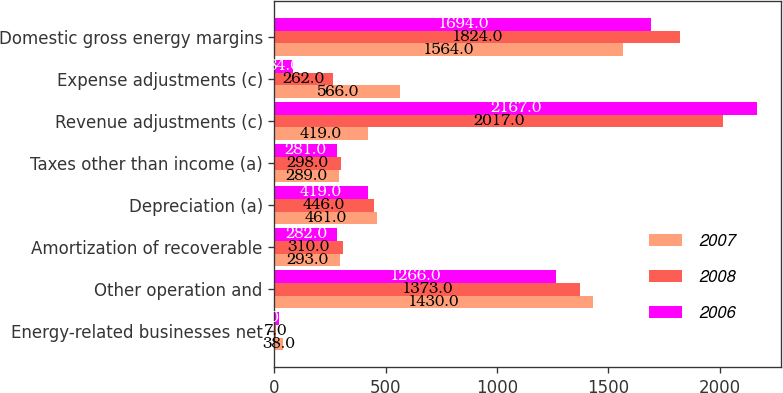<chart> <loc_0><loc_0><loc_500><loc_500><stacked_bar_chart><ecel><fcel>Energy-related businesses net<fcel>Other operation and<fcel>Amortization of recoverable<fcel>Depreciation (a)<fcel>Taxes other than income (a)<fcel>Revenue adjustments (c)<fcel>Expense adjustments (c)<fcel>Domestic gross energy margins<nl><fcel>2007<fcel>38<fcel>1430<fcel>293<fcel>461<fcel>289<fcel>419<fcel>566<fcel>1564<nl><fcel>2008<fcel>7<fcel>1373<fcel>310<fcel>446<fcel>298<fcel>2017<fcel>262<fcel>1824<nl><fcel>2006<fcel>20<fcel>1266<fcel>282<fcel>419<fcel>281<fcel>2167<fcel>84<fcel>1694<nl></chart> 